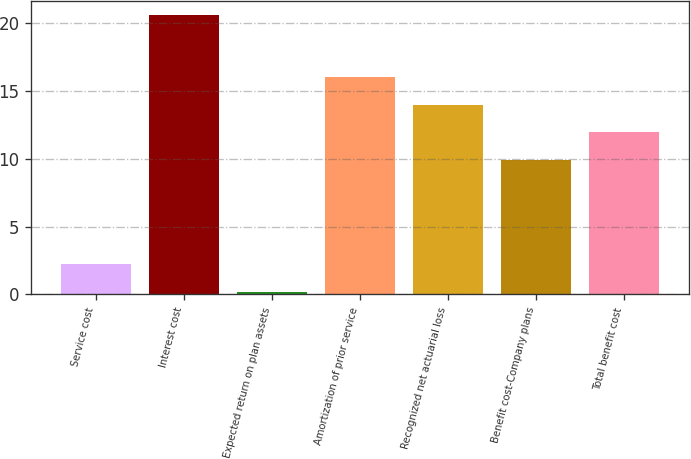Convert chart to OTSL. <chart><loc_0><loc_0><loc_500><loc_500><bar_chart><fcel>Service cost<fcel>Interest cost<fcel>Expected return on plan assets<fcel>Amortization of prior service<fcel>Recognized net actuarial loss<fcel>Benefit cost-Company plans<fcel>Total benefit cost<nl><fcel>2.24<fcel>20.6<fcel>0.2<fcel>16.02<fcel>13.98<fcel>9.9<fcel>11.94<nl></chart> 